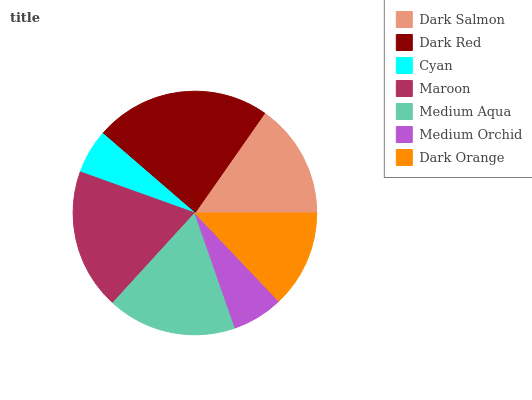Is Cyan the minimum?
Answer yes or no. Yes. Is Dark Red the maximum?
Answer yes or no. Yes. Is Dark Red the minimum?
Answer yes or no. No. Is Cyan the maximum?
Answer yes or no. No. Is Dark Red greater than Cyan?
Answer yes or no. Yes. Is Cyan less than Dark Red?
Answer yes or no. Yes. Is Cyan greater than Dark Red?
Answer yes or no. No. Is Dark Red less than Cyan?
Answer yes or no. No. Is Dark Salmon the high median?
Answer yes or no. Yes. Is Dark Salmon the low median?
Answer yes or no. Yes. Is Maroon the high median?
Answer yes or no. No. Is Dark Red the low median?
Answer yes or no. No. 